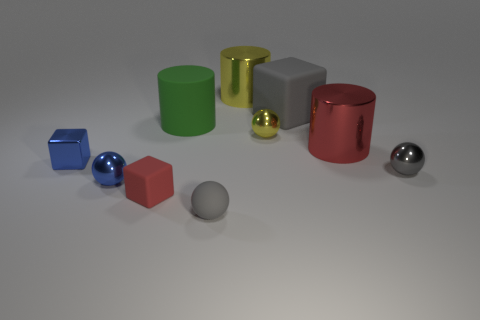Subtract all cylinders. How many objects are left? 7 Add 3 tiny blocks. How many tiny blocks are left? 5 Add 3 brown shiny cubes. How many brown shiny cubes exist? 3 Subtract 1 red blocks. How many objects are left? 9 Subtract all tiny gray matte objects. Subtract all shiny blocks. How many objects are left? 8 